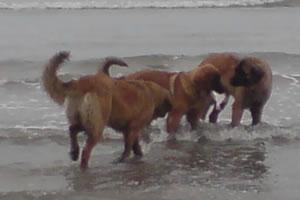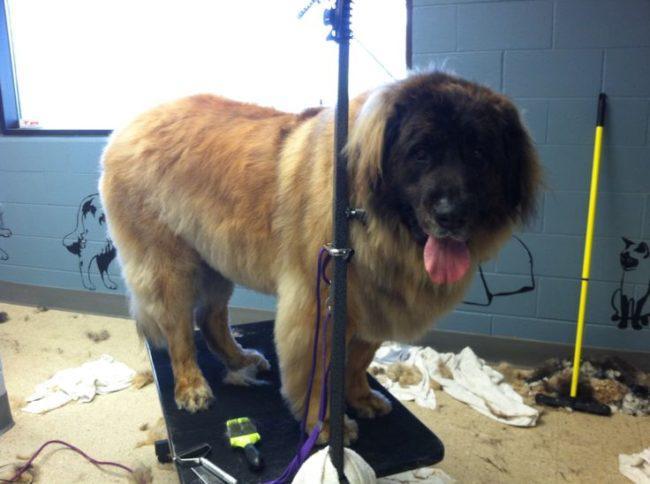The first image is the image on the left, the second image is the image on the right. Evaluate the accuracy of this statement regarding the images: "There's at least one human petting a dog.". Is it true? Answer yes or no. No. The first image is the image on the left, the second image is the image on the right. For the images shown, is this caption "There are three dogs in one of the images." true? Answer yes or no. Yes. 